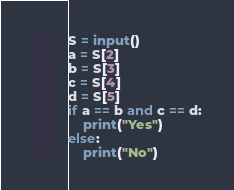Convert code to text. <code><loc_0><loc_0><loc_500><loc_500><_Python_>S = input()
a = S[2]
b = S[3]
c = S[4]
d = S[5]
if a == b and c == d:
    print("Yes")
else:
    print("No")
</code> 